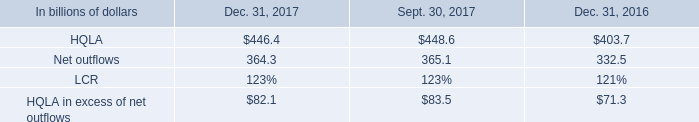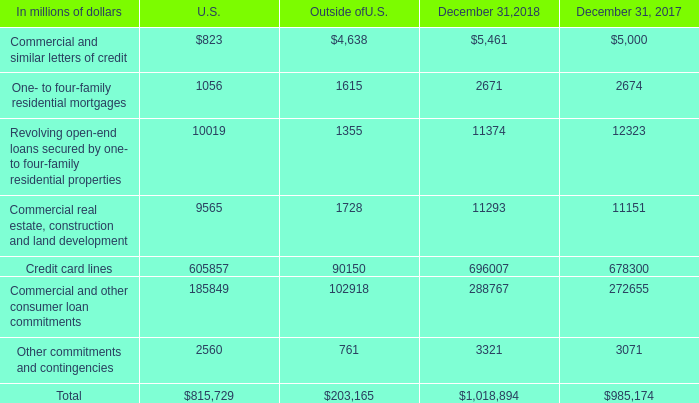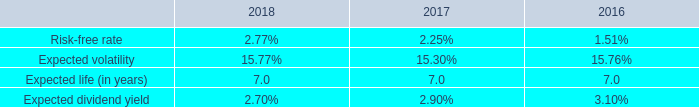What is the growing rate of Commercial and similar letters of credit in the years with the least Total? 
Computations: ((5461 - 5000) / 5000)
Answer: 0.0922. 